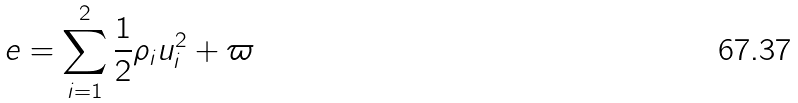<formula> <loc_0><loc_0><loc_500><loc_500>e = \sum _ { i = 1 } ^ { 2 } \frac { 1 } { 2 } \rho _ { i } u _ { i } ^ { 2 } + \varpi</formula> 